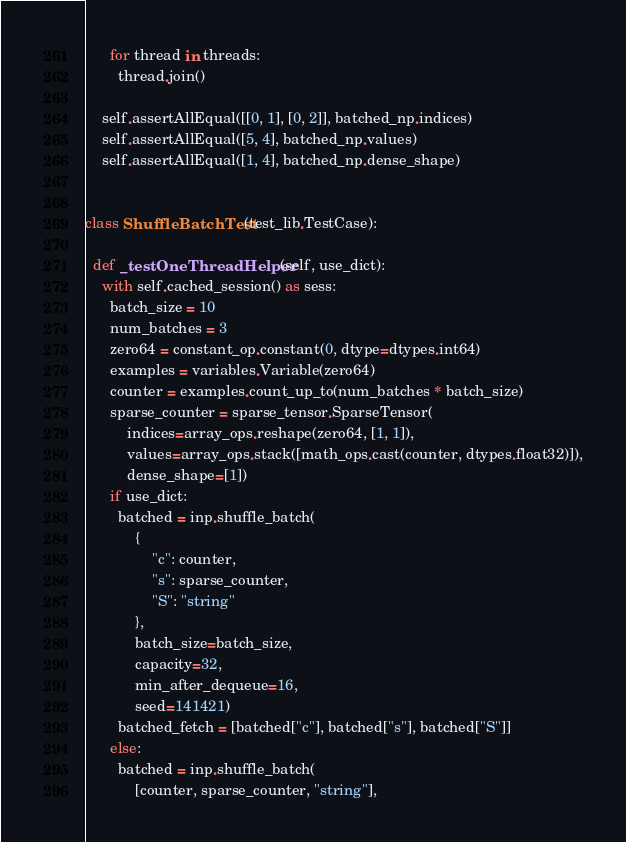<code> <loc_0><loc_0><loc_500><loc_500><_Python_>      for thread in threads:
        thread.join()

    self.assertAllEqual([[0, 1], [0, 2]], batched_np.indices)
    self.assertAllEqual([5, 4], batched_np.values)
    self.assertAllEqual([1, 4], batched_np.dense_shape)


class ShuffleBatchTest(test_lib.TestCase):

  def _testOneThreadHelper(self, use_dict):
    with self.cached_session() as sess:
      batch_size = 10
      num_batches = 3
      zero64 = constant_op.constant(0, dtype=dtypes.int64)
      examples = variables.Variable(zero64)
      counter = examples.count_up_to(num_batches * batch_size)
      sparse_counter = sparse_tensor.SparseTensor(
          indices=array_ops.reshape(zero64, [1, 1]),
          values=array_ops.stack([math_ops.cast(counter, dtypes.float32)]),
          dense_shape=[1])
      if use_dict:
        batched = inp.shuffle_batch(
            {
                "c": counter,
                "s": sparse_counter,
                "S": "string"
            },
            batch_size=batch_size,
            capacity=32,
            min_after_dequeue=16,
            seed=141421)
        batched_fetch = [batched["c"], batched["s"], batched["S"]]
      else:
        batched = inp.shuffle_batch(
            [counter, sparse_counter, "string"],</code> 